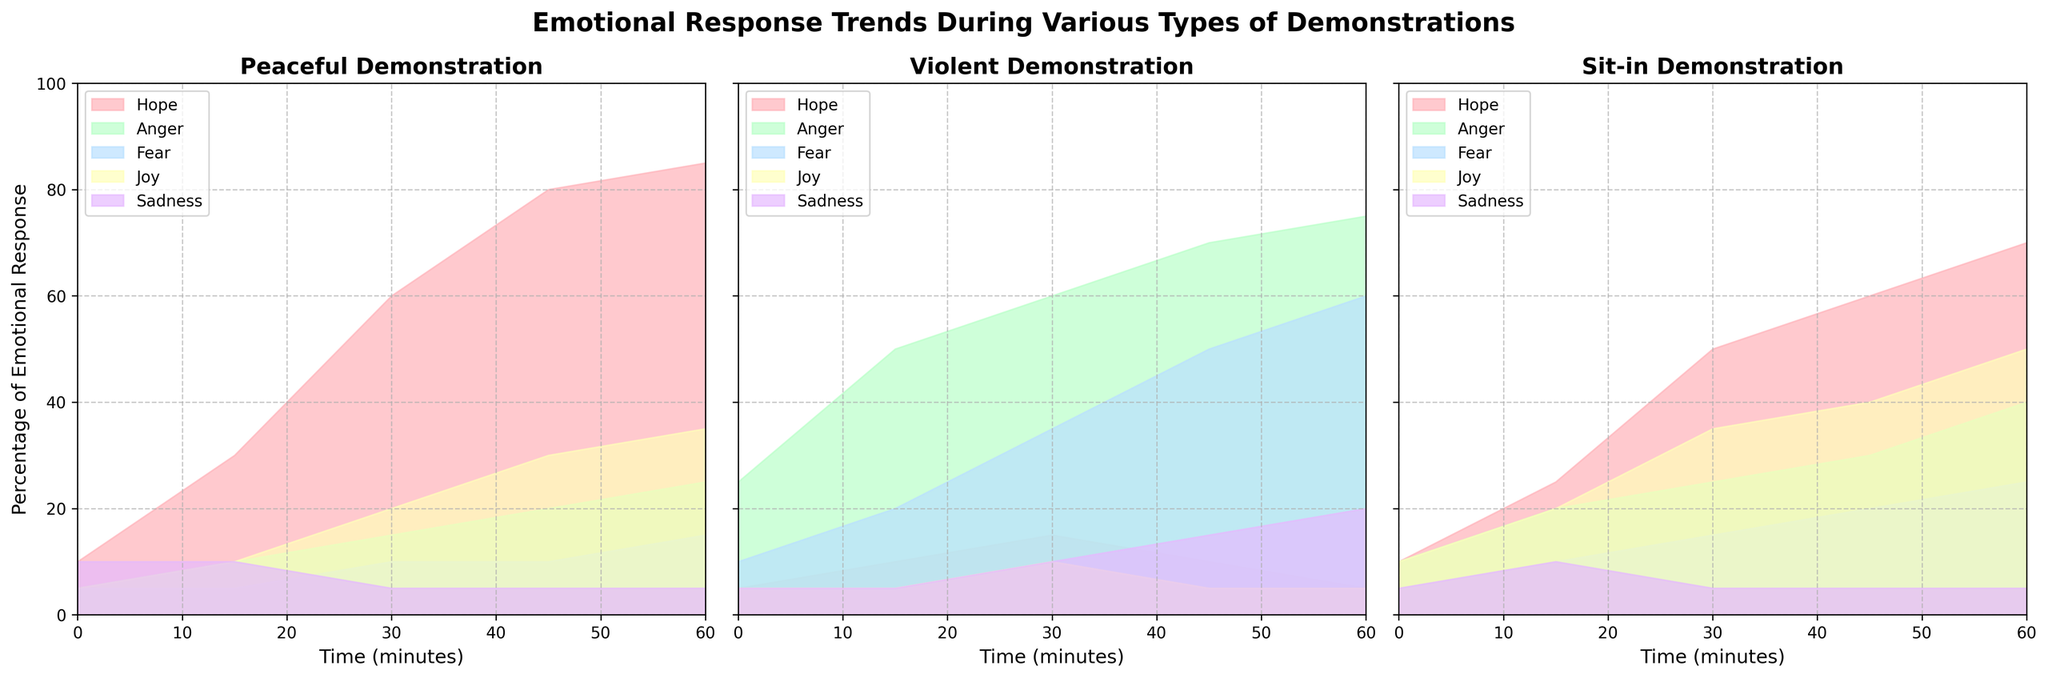What is the title of the figure? The title of the figure can be found at the top of the chart. It is displayed in bold and large font.
Answer: Emotional Response Trends During Various Types of Demonstrations Which emotion reaches the highest percentage during a Peaceful demonstration? By looking at the Peaceful demonstration plot, observe the maximum percentage values of each emotion. Hope reaches up to 85%.
Answer: Hope What is the trend of Anger percentage over time during Violent demonstrations? Examine the plot for Violent demonstrations and track the Anger emotion. The percentage increases consistently from 25% to 75%.
Answer: Increasing At what minute mark do Fear and Joy have the same percentage during a Sit-in demonstration? Look at the plot for Sit-in demonstrations and find where the lines for Fear and Joy intersect. They both have 10% at the 15-minute mark.
Answer: 15 How does the percentage of Fear change in Peaceful demonstrations from start to finish? Identify the Fear percentages at both the start (0 minutes) and finish (60 minutes) of a Peaceful demonstration, which change from 5% to 15%.
Answer: Increases Compare the maximum percentage of Hope in Peaceful vs. Violent demonstrations. Check the highest percentage of Hope in both demonstration types. Hope reaches 85% in Peaceful and only 15% in Violent demonstrations.
Answer: 85% vs. 15% Which emotion shows the greatest increase in percentage during a Sit-in demonstration? Identify the emotion with the largest difference between the start and end values in Sit-in demonstrations. Hope increases from 10% to 70%.
Answer: Hope Is Sadness more prominent in Violent or Peaceful demonstrations at the 60-minute mark? Compare the Sadness percentage at the 60-minute mark for both Violent and Peaceful demonstrations. It is 20% in Violent and 5% in Peaceful demonstrations.
Answer: Violent During which type of demonstration do all emotions stay below 50%? Evaluate each plot and identify where no emotion exceeds 50%. For Peaceful demonstrations, all emotions except Hope and Joy stay below 50%.
Answer: None of them What is the trend of Joy over time in Sit-in demonstrations, and how does it compare to its trend in Violent demonstrations? Analyze the trends of Joy over the time period for both Sit-in and Violent demonstrations. In Sit-ins, Joy increases from 10% to 50%, while in Violent demonstrations, it remains almost constant around 5-10%.
Answer: Increasing vs. Constant 